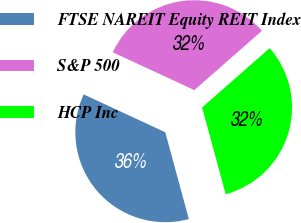<chart> <loc_0><loc_0><loc_500><loc_500><pie_chart><fcel>FTSE NAREIT Equity REIT Index<fcel>S&P 500<fcel>HCP Inc<nl><fcel>36.13%<fcel>31.62%<fcel>32.25%<nl></chart> 